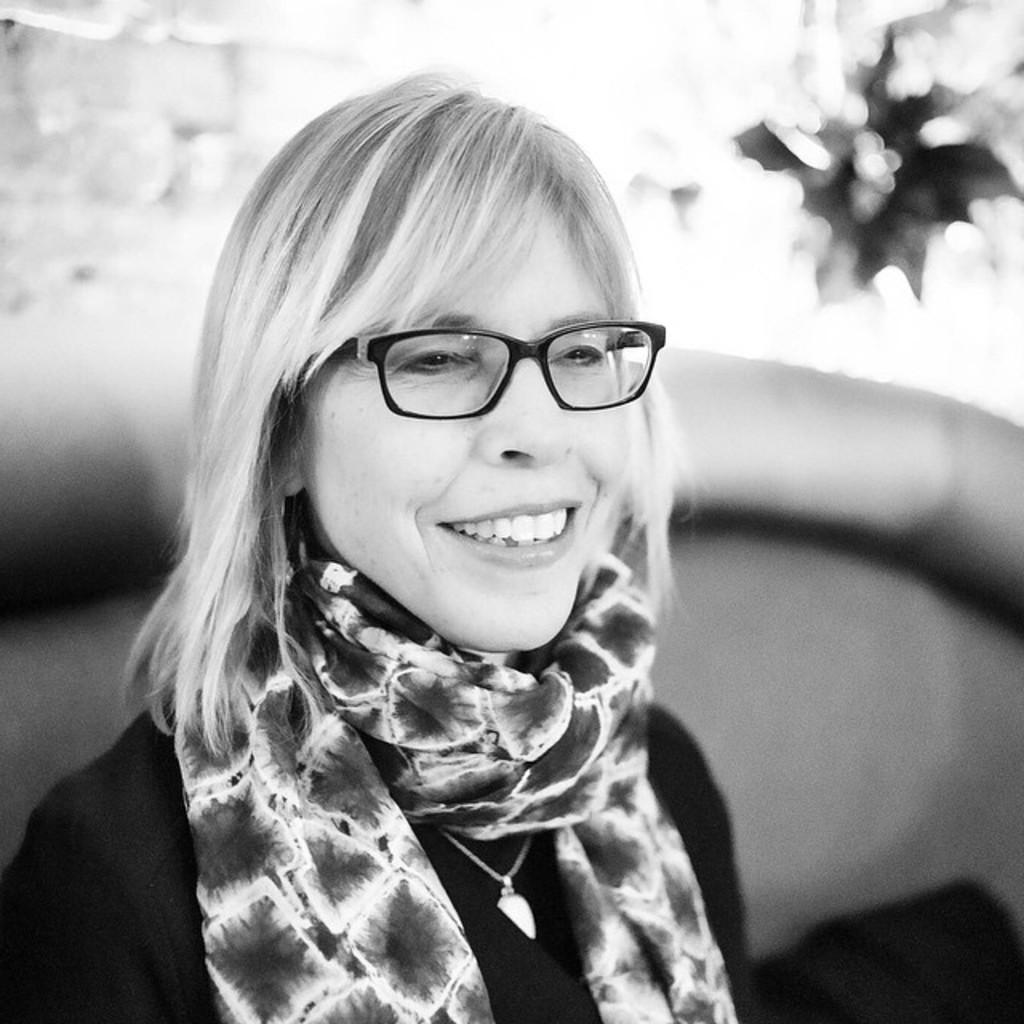Who is the main subject in the image? There is a woman in the image. What is the woman wearing on her face? The woman is wearing spectacles. What is the woman's facial expression in the image? The woman is smiling. Can you describe the background of the image? The background of the image is blurry. What type of print can be seen on the woman's shirt in the image? There is no print visible on the woman's shirt in the image. Is there a sink in the background of the image? There is no sink present in the image. Can you see a volcano erupting in the background of the image? There is no volcano present in the image. 